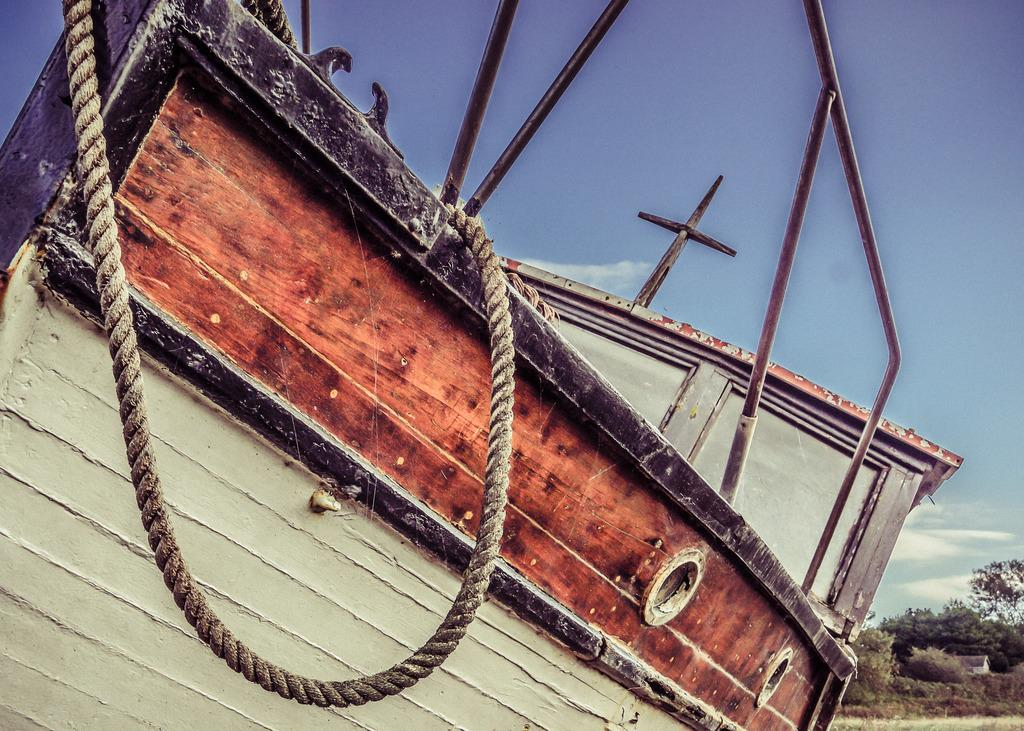What is the main subject of the image? There is a boat in the image. What other objects can be seen in the image? There are metal rods and a rope visible in the image. What can be seen in the background of the image? There are trees and clouds in the background of the image. What type of cherries are being served at the feast in the image? There is no feast or cherries present in the image; it features a boat, metal rods, a rope, trees, and clouds. How many horses are visible in the image? There are no horses present in the image. 